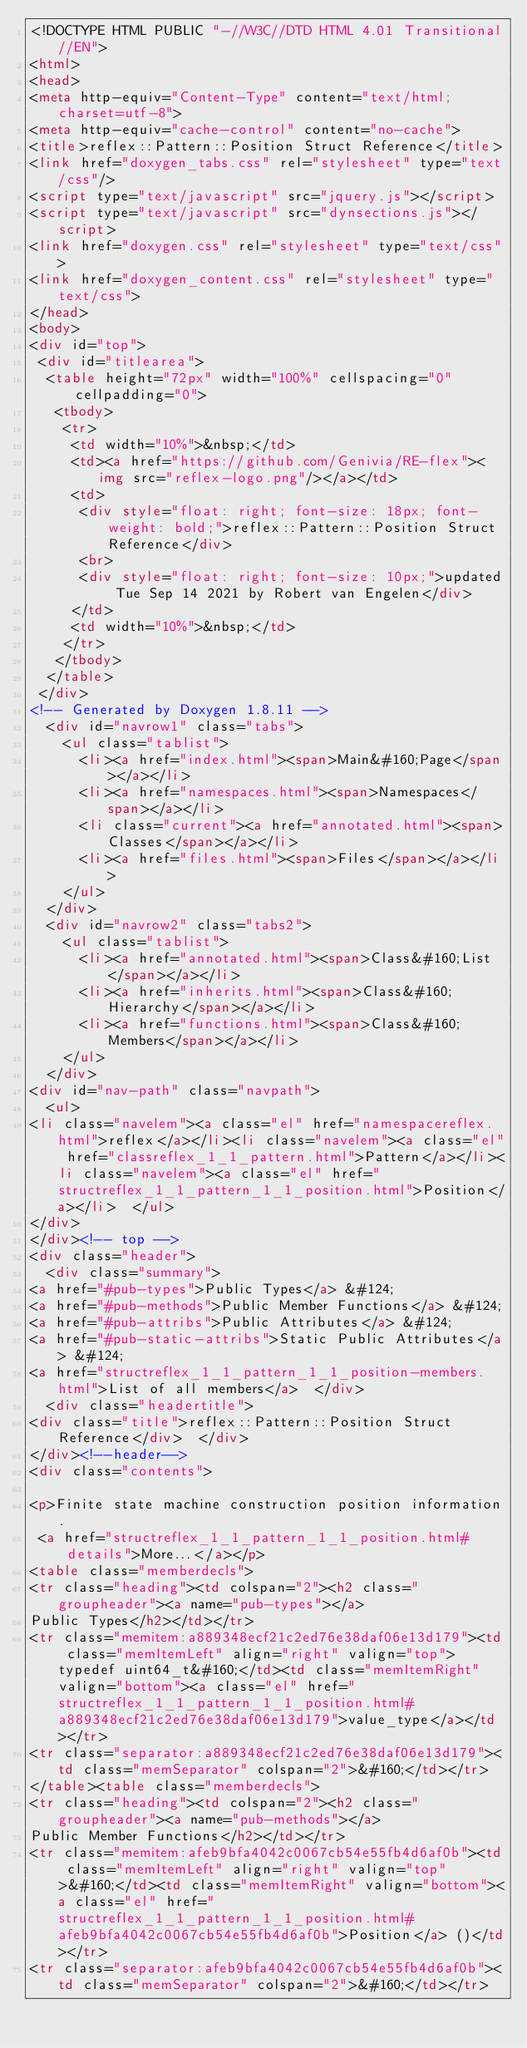Convert code to text. <code><loc_0><loc_0><loc_500><loc_500><_HTML_><!DOCTYPE HTML PUBLIC "-//W3C//DTD HTML 4.01 Transitional//EN">
<html>
<head>
<meta http-equiv="Content-Type" content="text/html;charset=utf-8">
<meta http-equiv="cache-control" content="no-cache">
<title>reflex::Pattern::Position Struct Reference</title>
<link href="doxygen_tabs.css" rel="stylesheet" type="text/css"/>
<script type="text/javascript" src="jquery.js"></script>
<script type="text/javascript" src="dynsections.js"></script>
<link href="doxygen.css" rel="stylesheet" type="text/css">
<link href="doxygen_content.css" rel="stylesheet" type="text/css">
</head>
<body>
<div id="top">
 <div id="titlearea">
  <table height="72px" width="100%" cellspacing="0" cellpadding="0">
   <tbody>
    <tr>
     <td width="10%">&nbsp;</td>
     <td><a href="https://github.com/Genivia/RE-flex"><img src="reflex-logo.png"/></a></td>
     <td>
      <div style="float: right; font-size: 18px; font-weight: bold;">reflex::Pattern::Position Struct Reference</div>
      <br>
      <div style="float: right; font-size: 10px;">updated Tue Sep 14 2021 by Robert van Engelen</div>
     </td>
     <td width="10%">&nbsp;</td>
    </tr>
   </tbody>
  </table>
 </div>
<!-- Generated by Doxygen 1.8.11 -->
  <div id="navrow1" class="tabs">
    <ul class="tablist">
      <li><a href="index.html"><span>Main&#160;Page</span></a></li>
      <li><a href="namespaces.html"><span>Namespaces</span></a></li>
      <li class="current"><a href="annotated.html"><span>Classes</span></a></li>
      <li><a href="files.html"><span>Files</span></a></li>
    </ul>
  </div>
  <div id="navrow2" class="tabs2">
    <ul class="tablist">
      <li><a href="annotated.html"><span>Class&#160;List</span></a></li>
      <li><a href="inherits.html"><span>Class&#160;Hierarchy</span></a></li>
      <li><a href="functions.html"><span>Class&#160;Members</span></a></li>
    </ul>
  </div>
<div id="nav-path" class="navpath">
  <ul>
<li class="navelem"><a class="el" href="namespacereflex.html">reflex</a></li><li class="navelem"><a class="el" href="classreflex_1_1_pattern.html">Pattern</a></li><li class="navelem"><a class="el" href="structreflex_1_1_pattern_1_1_position.html">Position</a></li>  </ul>
</div>
</div><!-- top -->
<div class="header">
  <div class="summary">
<a href="#pub-types">Public Types</a> &#124;
<a href="#pub-methods">Public Member Functions</a> &#124;
<a href="#pub-attribs">Public Attributes</a> &#124;
<a href="#pub-static-attribs">Static Public Attributes</a> &#124;
<a href="structreflex_1_1_pattern_1_1_position-members.html">List of all members</a>  </div>
  <div class="headertitle">
<div class="title">reflex::Pattern::Position Struct Reference</div>  </div>
</div><!--header-->
<div class="contents">

<p>Finite state machine construction position information.  
 <a href="structreflex_1_1_pattern_1_1_position.html#details">More...</a></p>
<table class="memberdecls">
<tr class="heading"><td colspan="2"><h2 class="groupheader"><a name="pub-types"></a>
Public Types</h2></td></tr>
<tr class="memitem:a889348ecf21c2ed76e38daf06e13d179"><td class="memItemLeft" align="right" valign="top">typedef uint64_t&#160;</td><td class="memItemRight" valign="bottom"><a class="el" href="structreflex_1_1_pattern_1_1_position.html#a889348ecf21c2ed76e38daf06e13d179">value_type</a></td></tr>
<tr class="separator:a889348ecf21c2ed76e38daf06e13d179"><td class="memSeparator" colspan="2">&#160;</td></tr>
</table><table class="memberdecls">
<tr class="heading"><td colspan="2"><h2 class="groupheader"><a name="pub-methods"></a>
Public Member Functions</h2></td></tr>
<tr class="memitem:afeb9bfa4042c0067cb54e55fb4d6af0b"><td class="memItemLeft" align="right" valign="top">&#160;</td><td class="memItemRight" valign="bottom"><a class="el" href="structreflex_1_1_pattern_1_1_position.html#afeb9bfa4042c0067cb54e55fb4d6af0b">Position</a> ()</td></tr>
<tr class="separator:afeb9bfa4042c0067cb54e55fb4d6af0b"><td class="memSeparator" colspan="2">&#160;</td></tr></code> 